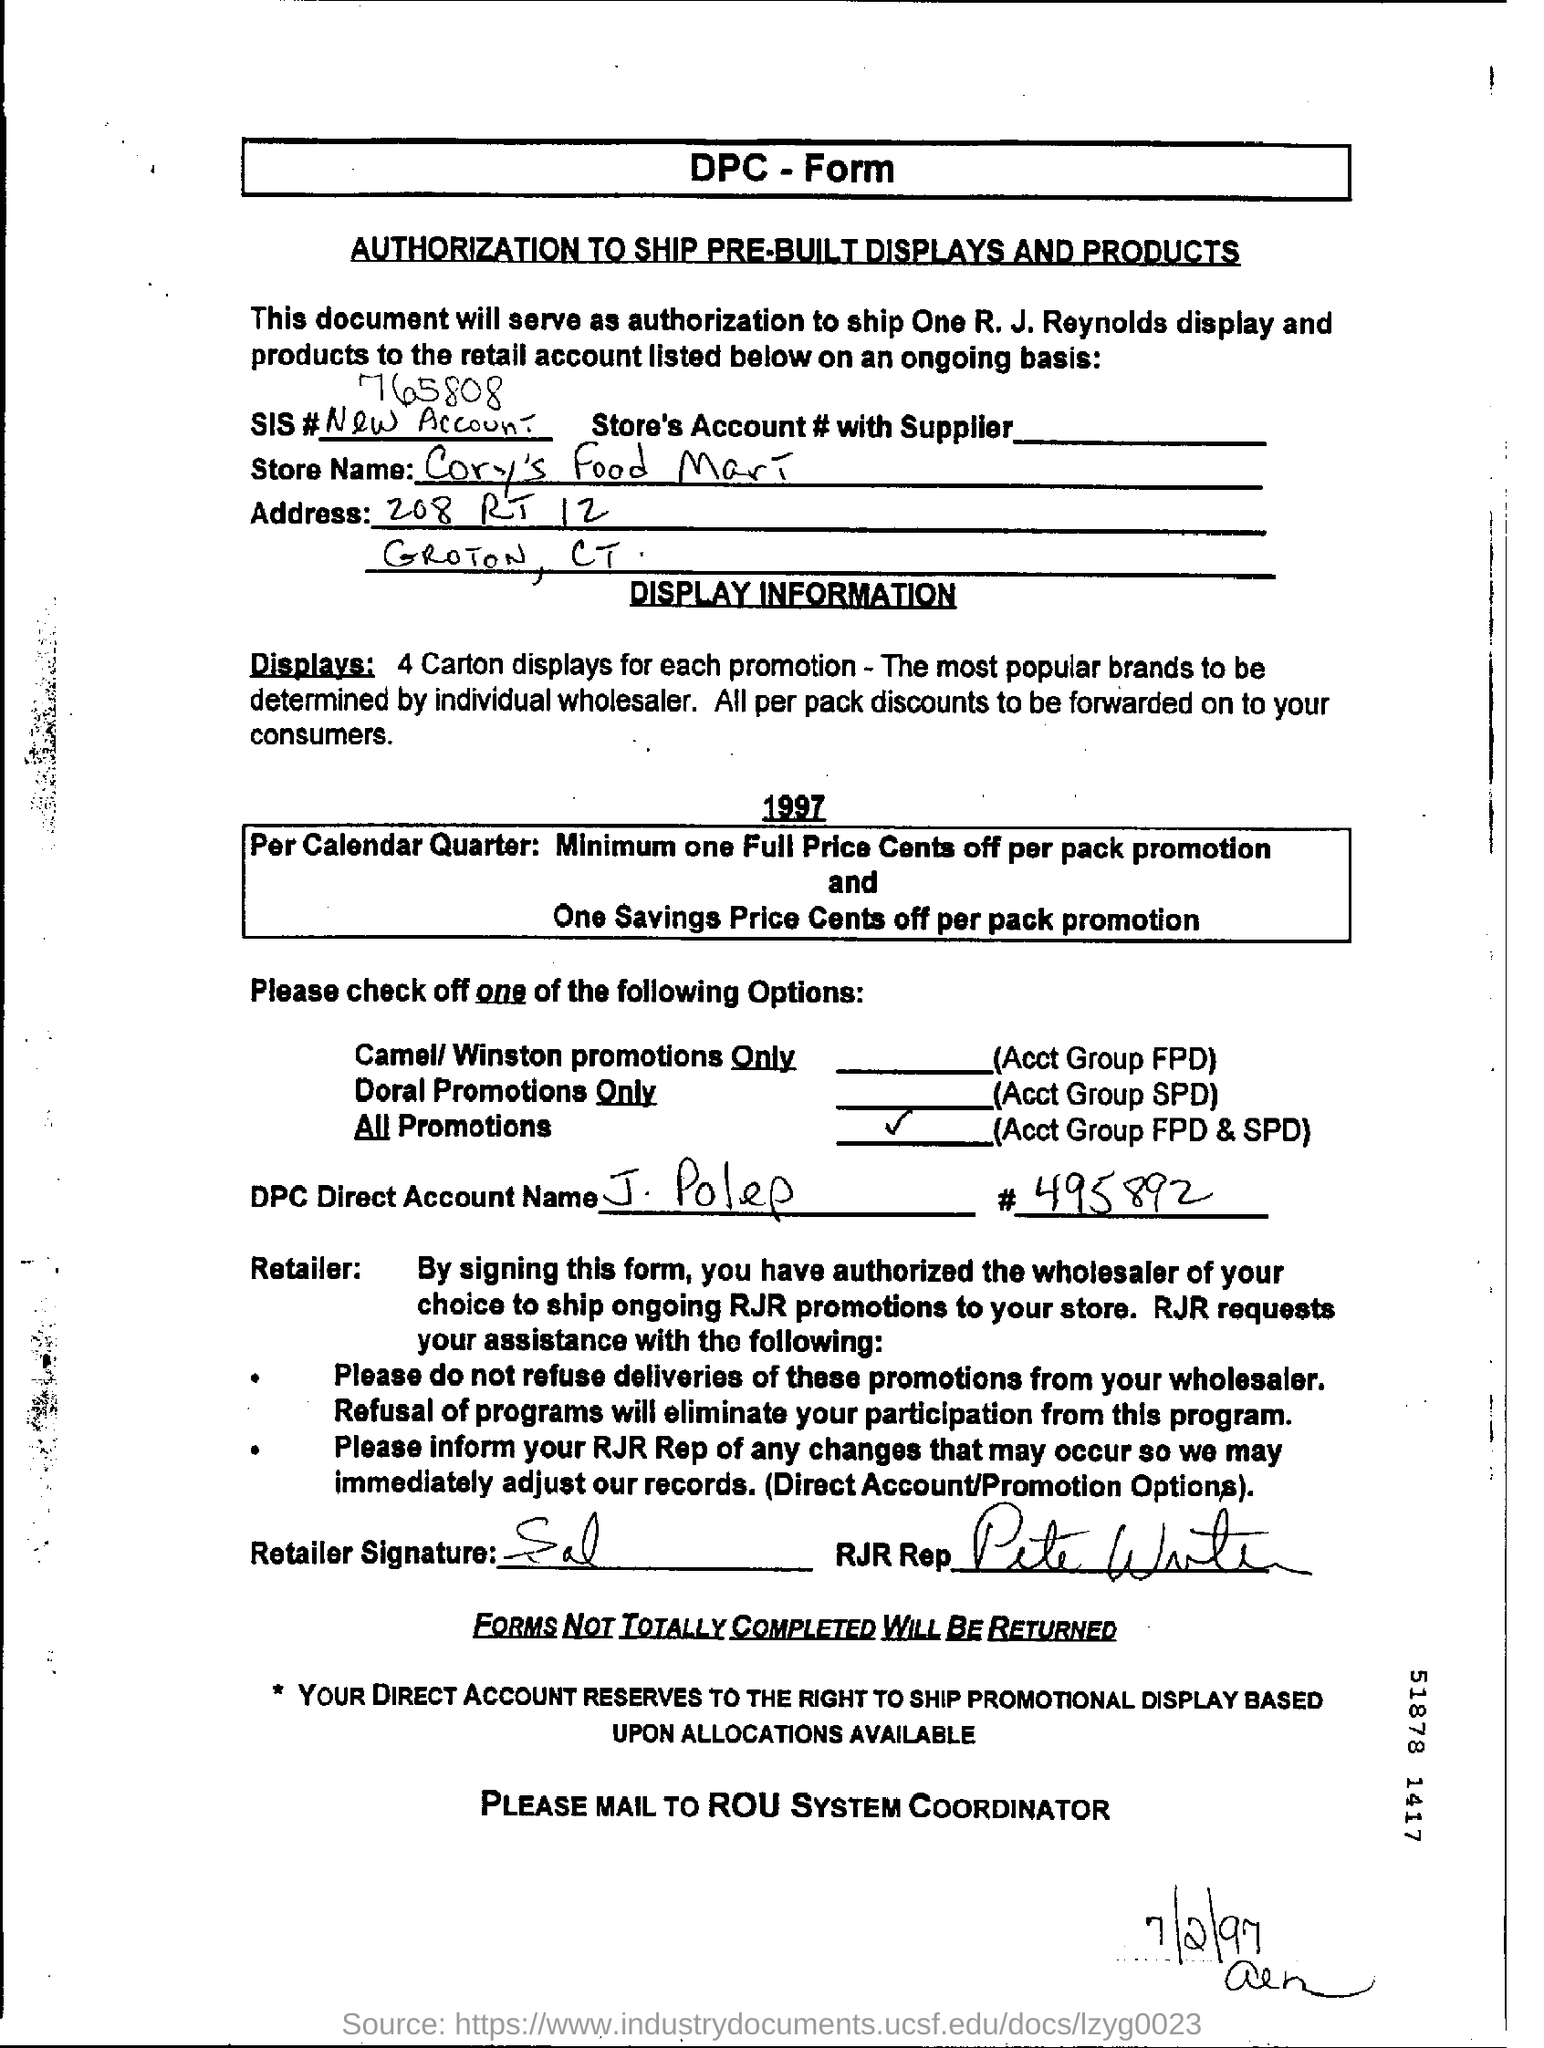Specify some key components in this picture. The DPC Direct Account Name is J. Polep. The SIS number is 765808... The date mentioned in the bottom of the document is July 2, 1997. The DPC Direct Account name is J. Polep. 